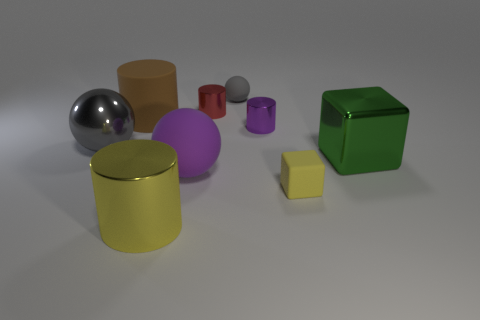What number of metallic things are either big green objects or tiny red objects?
Your answer should be compact. 2. There is a big ball that is to the left of the large brown matte cylinder; is there a small red thing that is on the left side of it?
Give a very brief answer. No. Do the big thing that is to the right of the tiny matte block and the large yellow object have the same material?
Provide a succinct answer. Yes. What number of other objects are there of the same color as the matte block?
Provide a short and direct response. 1. Is the metal sphere the same color as the big metal block?
Ensure brevity in your answer.  No. What is the size of the gray ball to the right of the shiny cylinder that is in front of the large shiny ball?
Your response must be concise. Small. Is the cylinder that is left of the big metallic cylinder made of the same material as the tiny gray thing behind the purple matte ball?
Your answer should be very brief. Yes. There is a large matte object behind the green metallic cube; does it have the same color as the matte block?
Make the answer very short. No. What number of metallic cylinders are to the left of the metal ball?
Make the answer very short. 0. Is the green cube made of the same material as the ball that is in front of the large gray metal ball?
Ensure brevity in your answer.  No. 